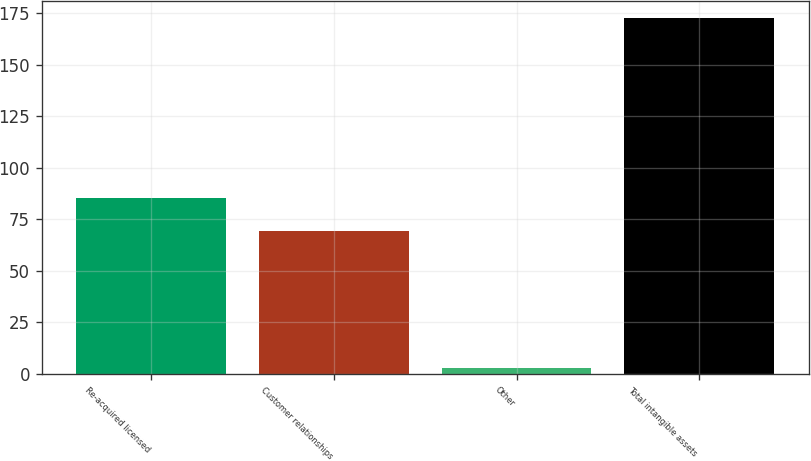Convert chart. <chart><loc_0><loc_0><loc_500><loc_500><bar_chart><fcel>Re-acquired licensed<fcel>Customer relationships<fcel>Other<fcel>Total intangible assets<nl><fcel>85.3<fcel>69.2<fcel>2.7<fcel>172.5<nl></chart> 